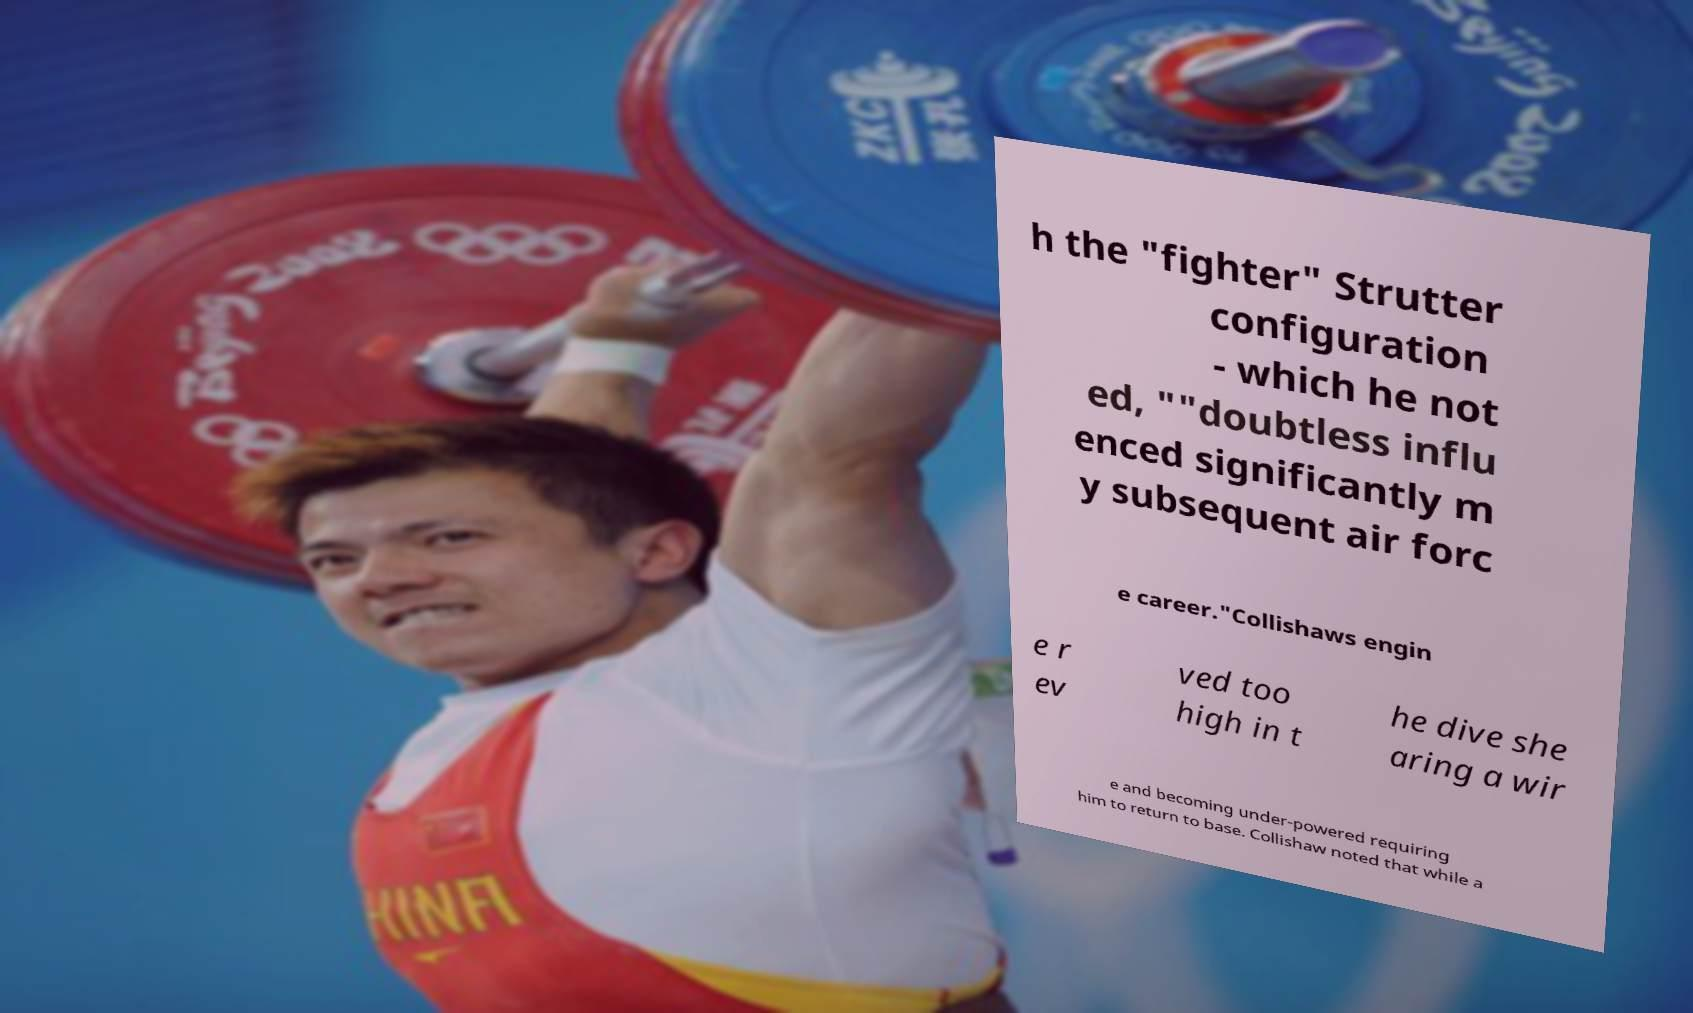Can you read and provide the text displayed in the image?This photo seems to have some interesting text. Can you extract and type it out for me? h the "fighter" Strutter configuration - which he not ed, ""doubtless influ enced significantly m y subsequent air forc e career."Collishaws engin e r ev ved too high in t he dive she aring a wir e and becoming under-powered requiring him to return to base. Collishaw noted that while a 